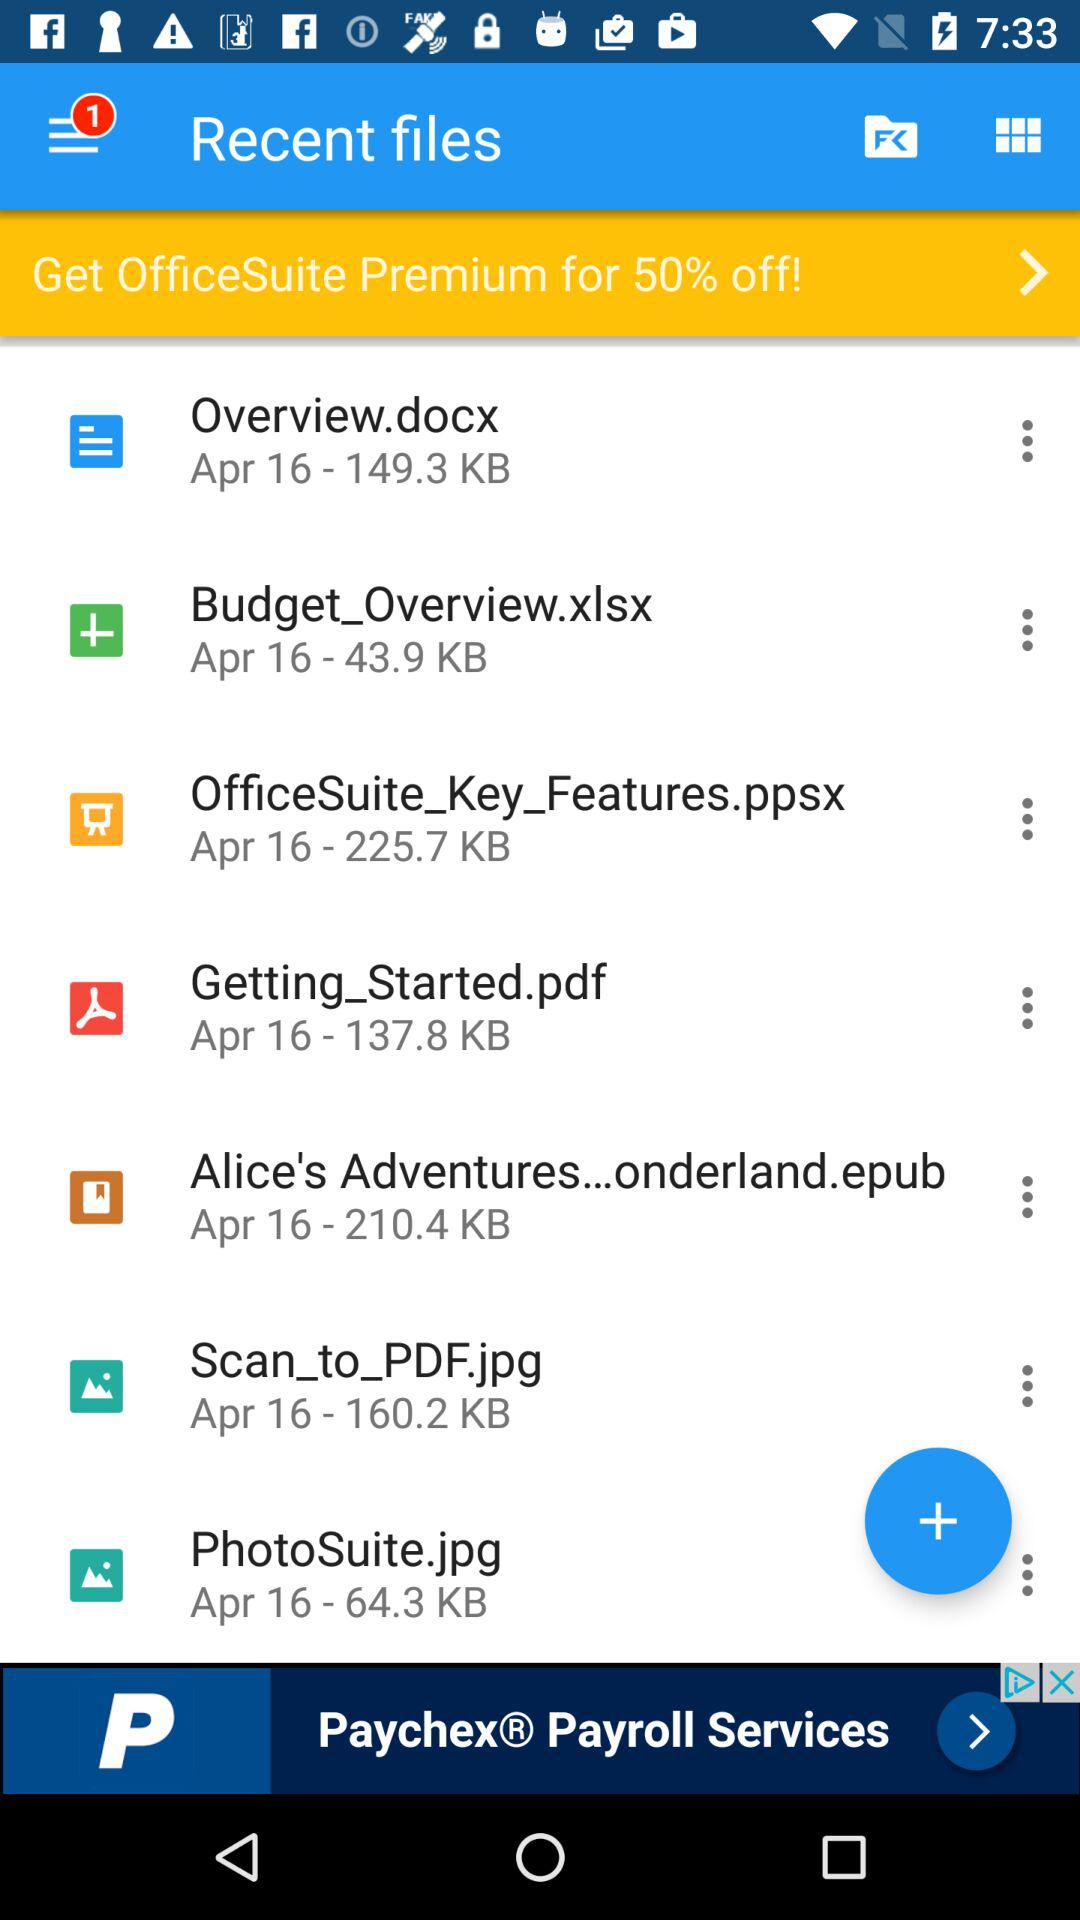What's the storage memory of Overview.docx? The storage memory is 149.3 KB. 